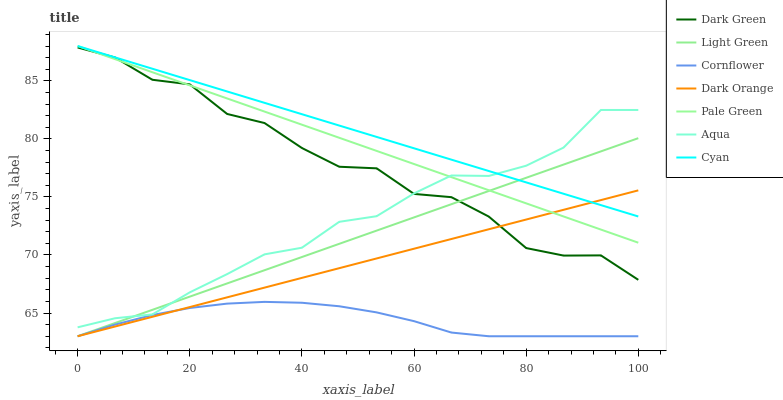Does Cornflower have the minimum area under the curve?
Answer yes or no. Yes. Does Cyan have the maximum area under the curve?
Answer yes or no. Yes. Does Aqua have the minimum area under the curve?
Answer yes or no. No. Does Aqua have the maximum area under the curve?
Answer yes or no. No. Is Light Green the smoothest?
Answer yes or no. Yes. Is Dark Green the roughest?
Answer yes or no. Yes. Is Cornflower the smoothest?
Answer yes or no. No. Is Cornflower the roughest?
Answer yes or no. No. Does Dark Orange have the lowest value?
Answer yes or no. Yes. Does Aqua have the lowest value?
Answer yes or no. No. Does Cyan have the highest value?
Answer yes or no. Yes. Does Aqua have the highest value?
Answer yes or no. No. Is Dark Green less than Cyan?
Answer yes or no. Yes. Is Aqua greater than Cornflower?
Answer yes or no. Yes. Does Cornflower intersect Light Green?
Answer yes or no. Yes. Is Cornflower less than Light Green?
Answer yes or no. No. Is Cornflower greater than Light Green?
Answer yes or no. No. Does Dark Green intersect Cyan?
Answer yes or no. No. 